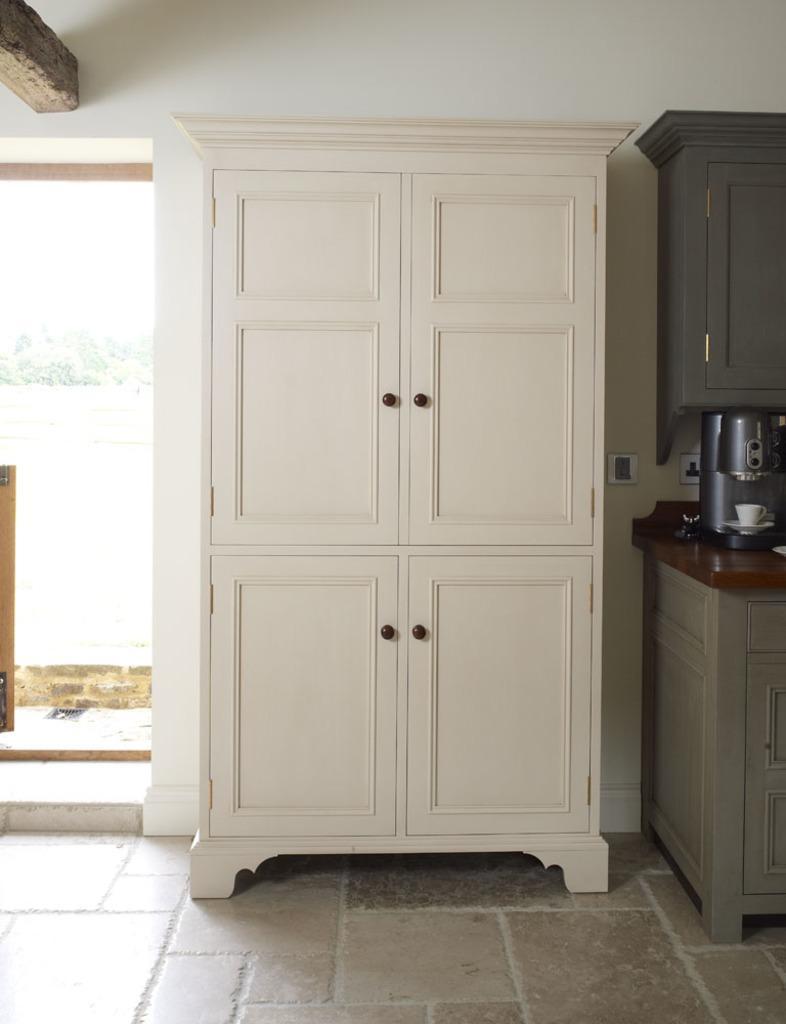In one or two sentences, can you explain what this image depicts? In this image, I can see a wardrobe on the floor. On the right side of the image, I can see a cup and saucer on the coffee machine, which is placed on a table and a cupboard attached to the wall. On the left side of the image, this is an entrance. 